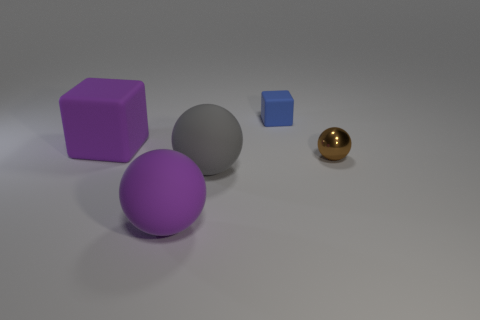Add 1 big things. How many objects exist? 6 Subtract all spheres. How many objects are left? 2 Subtract 1 purple blocks. How many objects are left? 4 Subtract all big rubber balls. Subtract all large matte cubes. How many objects are left? 2 Add 4 gray rubber objects. How many gray rubber objects are left? 5 Add 1 rubber spheres. How many rubber spheres exist? 3 